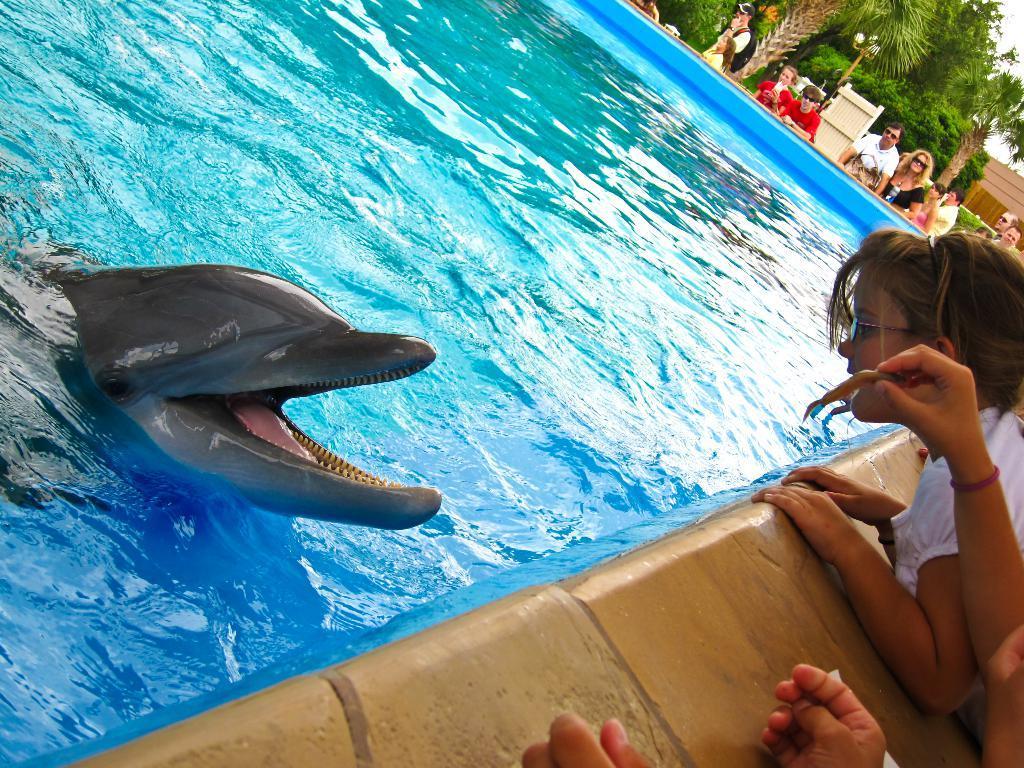Can you describe this image briefly? In this image there is a dolphin in the pool, there are a few people around the pool, there are few trees, lights and a building. 